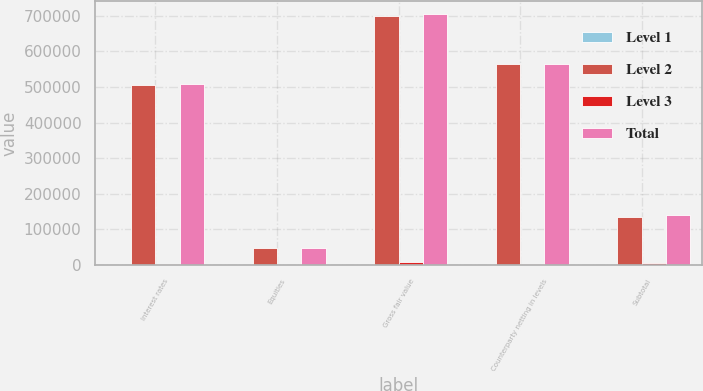<chart> <loc_0><loc_0><loc_500><loc_500><stacked_bar_chart><ecel><fcel>Interest rates<fcel>Equities<fcel>Gross fair value<fcel>Counterparty netting in levels<fcel>Subtotal<nl><fcel>Level 1<fcel>46<fcel>1<fcel>47<fcel>12<fcel>35<nl><fcel>Level 2<fcel>506818<fcel>47667<fcel>699585<fcel>564100<fcel>135485<nl><fcel>Level 3<fcel>614<fcel>424<fcel>6607<fcel>1417<fcel>5190<nl><fcel>Total<fcel>507478<fcel>48092<fcel>706239<fcel>565529<fcel>140710<nl></chart> 